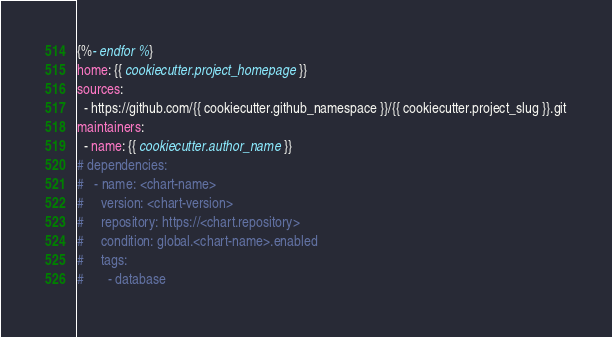Convert code to text. <code><loc_0><loc_0><loc_500><loc_500><_YAML_>{%- endfor %}
home: {{ cookiecutter.project_homepage }}
sources:
  - https://github.com/{{ cookiecutter.github_namespace }}/{{ cookiecutter.project_slug }}.git
maintainers:
  - name: {{ cookiecutter.author_name }}
# dependencies:
#   - name: <chart-name>
#     version: <chart-version>
#     repository: https://<chart.repository>
#     condition: global.<chart-name>.enabled
#     tags:
#       - database
</code> 